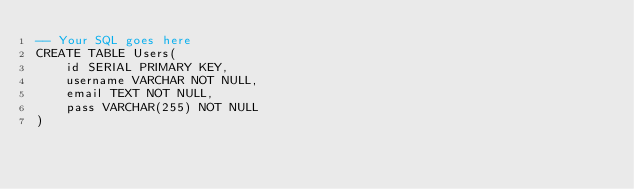Convert code to text. <code><loc_0><loc_0><loc_500><loc_500><_SQL_>-- Your SQL goes here
CREATE TABLE Users(
    id SERIAL PRIMARY KEY,
    username VARCHAR NOT NULL,
    email TEXT NOT NULL,
    pass VARCHAR(255) NOT NULL
)</code> 